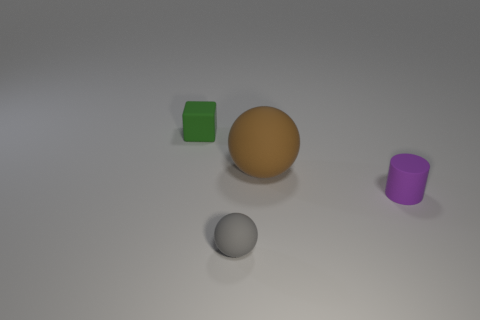Add 3 tiny gray rubber spheres. How many objects exist? 7 Add 3 matte things. How many matte things are left? 7 Add 1 small matte things. How many small matte things exist? 4 Subtract all gray balls. How many balls are left? 1 Subtract 0 blue blocks. How many objects are left? 4 Subtract all cubes. How many objects are left? 3 Subtract all purple spheres. Subtract all purple blocks. How many spheres are left? 2 Subtract all yellow cubes. How many brown spheres are left? 1 Subtract all tiny blue cylinders. Subtract all small balls. How many objects are left? 3 